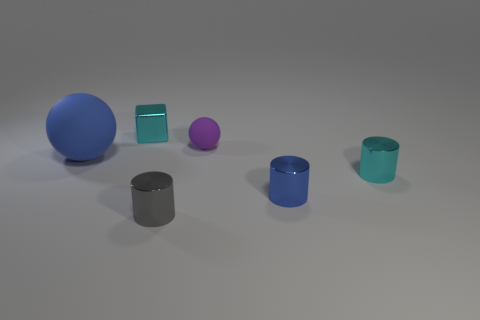What is the material of the tiny cyan object that is to the left of the tiny purple matte ball?
Your response must be concise. Metal. Is the number of purple spheres greater than the number of cyan shiny objects?
Make the answer very short. No. Is the shape of the metallic object that is to the right of the small blue object the same as  the small purple rubber object?
Ensure brevity in your answer.  No. How many rubber objects are behind the large blue sphere and left of the tiny purple ball?
Offer a terse response. 0. How many other gray metallic things have the same shape as the tiny gray metallic thing?
Your answer should be compact. 0. The metallic object behind the tiny cyan metallic object in front of the big rubber sphere is what color?
Provide a short and direct response. Cyan. Does the blue matte object have the same shape as the cyan thing to the right of the blue cylinder?
Your answer should be compact. No. There is a tiny cyan object that is on the right side of the cyan shiny thing that is behind the tiny cyan shiny object in front of the small cyan metallic cube; what is it made of?
Provide a succinct answer. Metal. Are there any green metallic spheres that have the same size as the shiny cube?
Keep it short and to the point. No. There is a blue ball that is the same material as the purple sphere; what size is it?
Your answer should be compact. Large. 